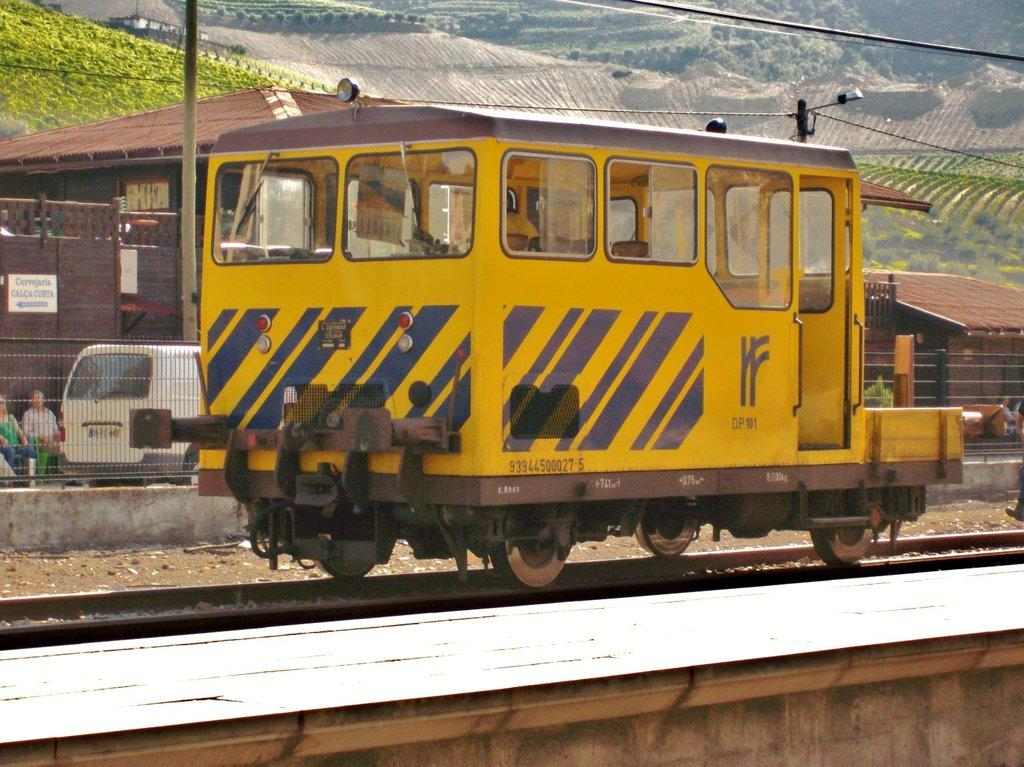What is the main subject in the foreground of the image? There is a rail vehicle on the railway track in the foreground of the image. What can be seen in the background of the image? In the background of the image, there is a railing, poles, cables, huts, and greenery on a slope. Can you describe the railing in the background? The railing is a safety feature that can be seen in the background of the image. What type of structures are the huts in the background? The huts in the background are small, simple dwellings. How does the dust affect the route of the rail vehicle in the image? There is no mention of dust in the image, so it cannot be determined how it might affect the route of the rail vehicle. 